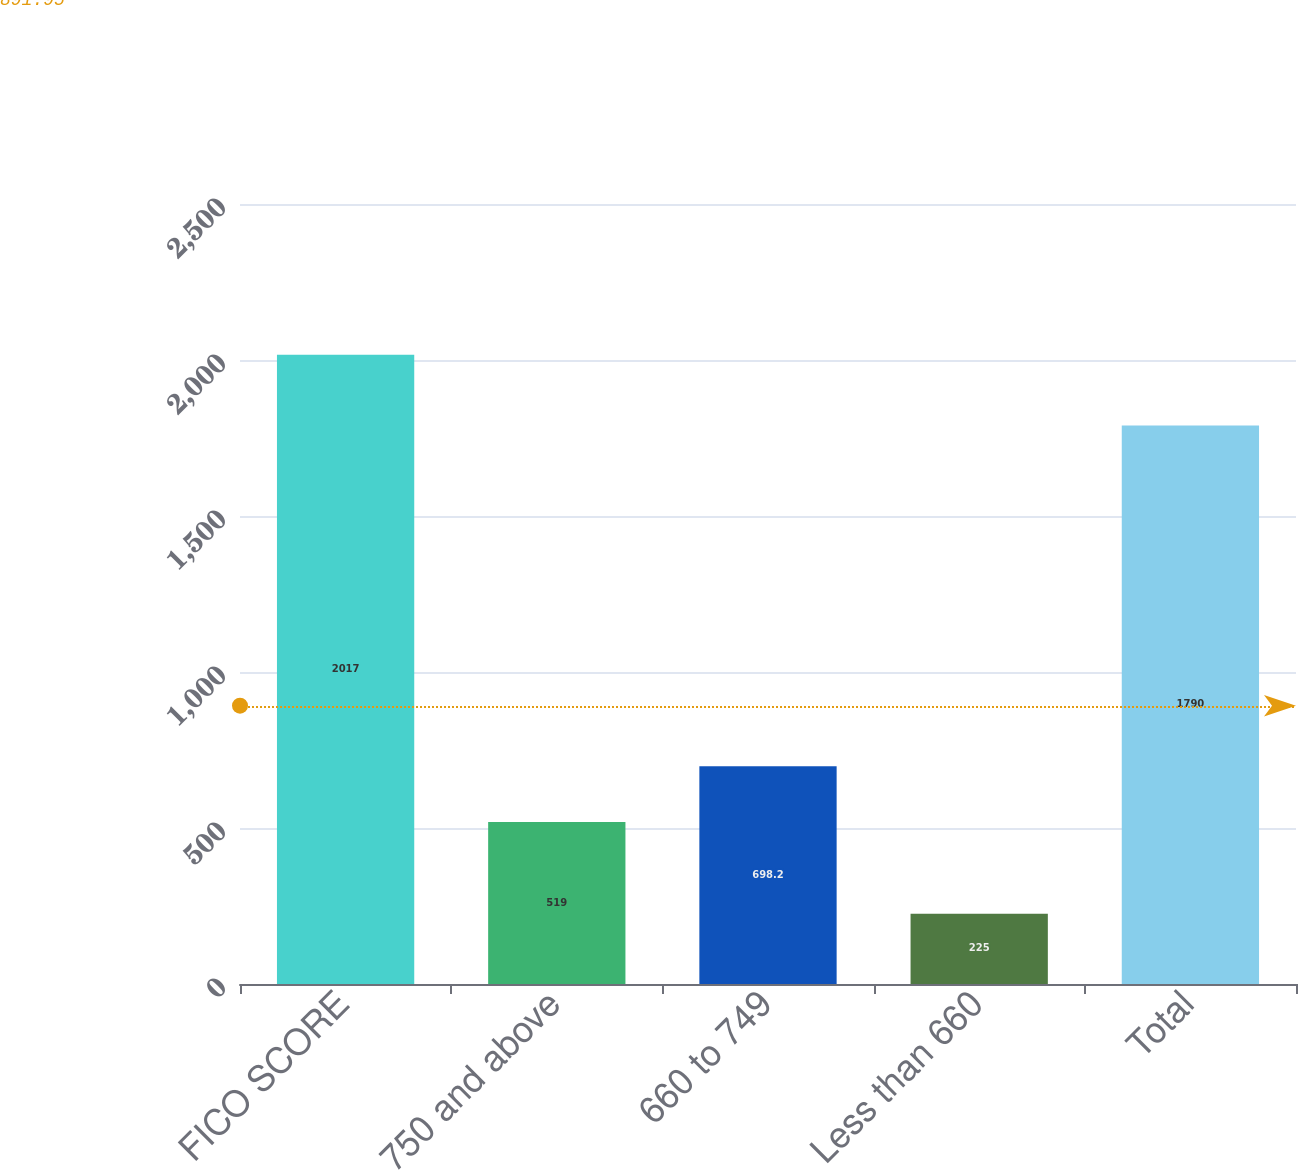Convert chart. <chart><loc_0><loc_0><loc_500><loc_500><bar_chart><fcel>FICO SCORE<fcel>750 and above<fcel>660 to 749<fcel>Less than 660<fcel>Total<nl><fcel>2017<fcel>519<fcel>698.2<fcel>225<fcel>1790<nl></chart> 